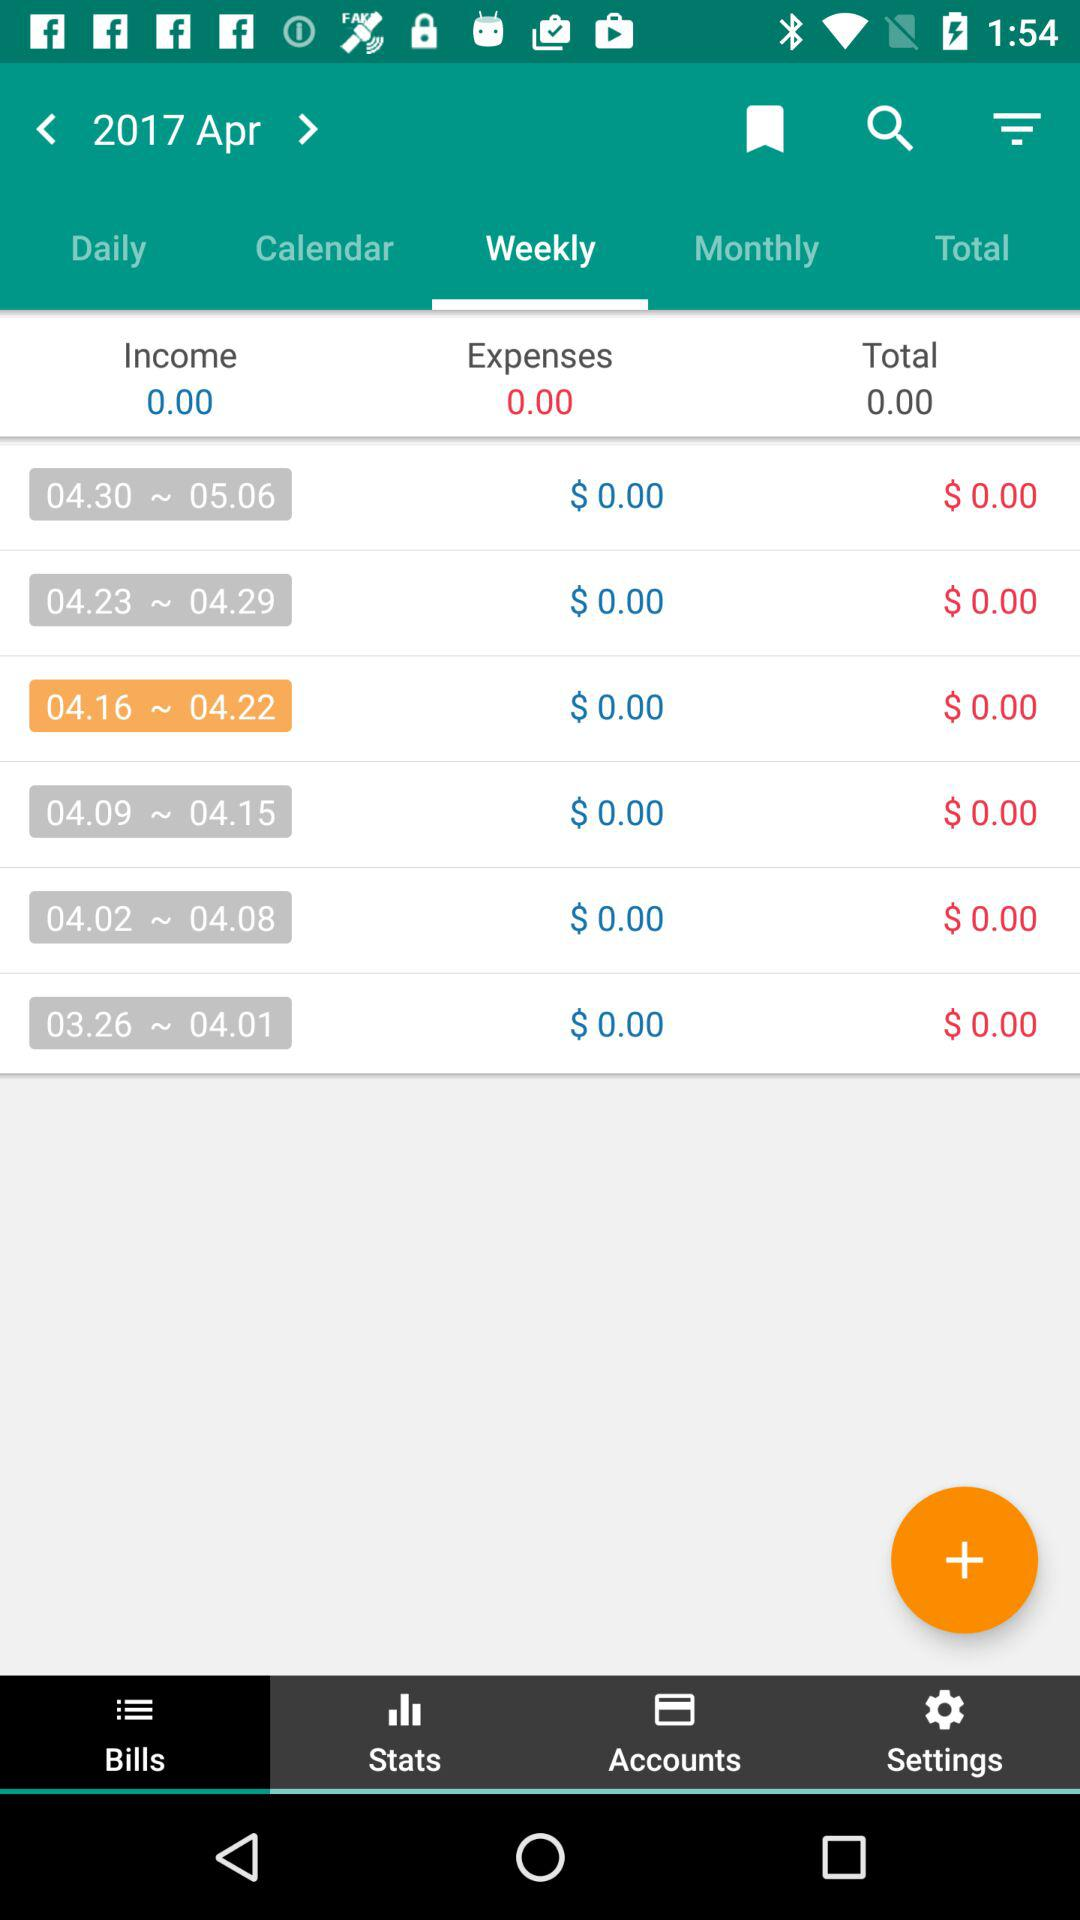What is the income? The income is 0.00. 